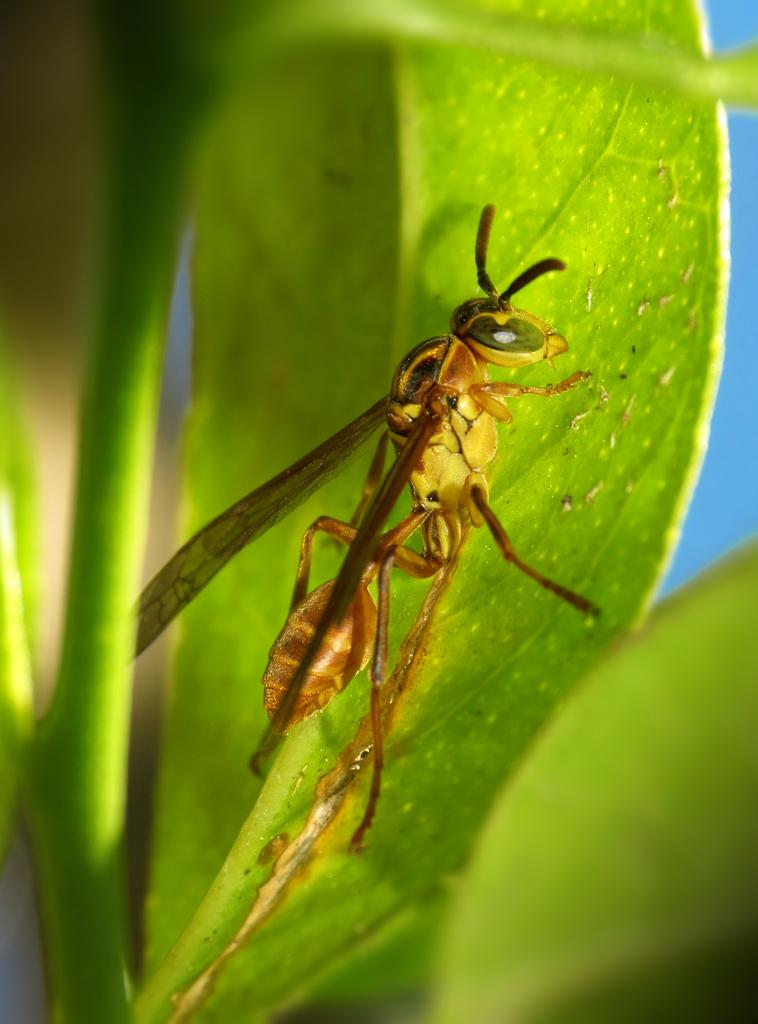What is present on the green leaf in the image? There is an insect on a green leaf in the image. What else can be seen in the image besides the insect and leaf? There are stems visible in the image. How would you describe the background of the image? The background has a blurred view. Where is the lunchroom located in the image? There is no lunchroom present in the image; it features an insect on a green leaf with stems and a blurred background. Can you see any pets in the image? There are no pets visible in the image. 